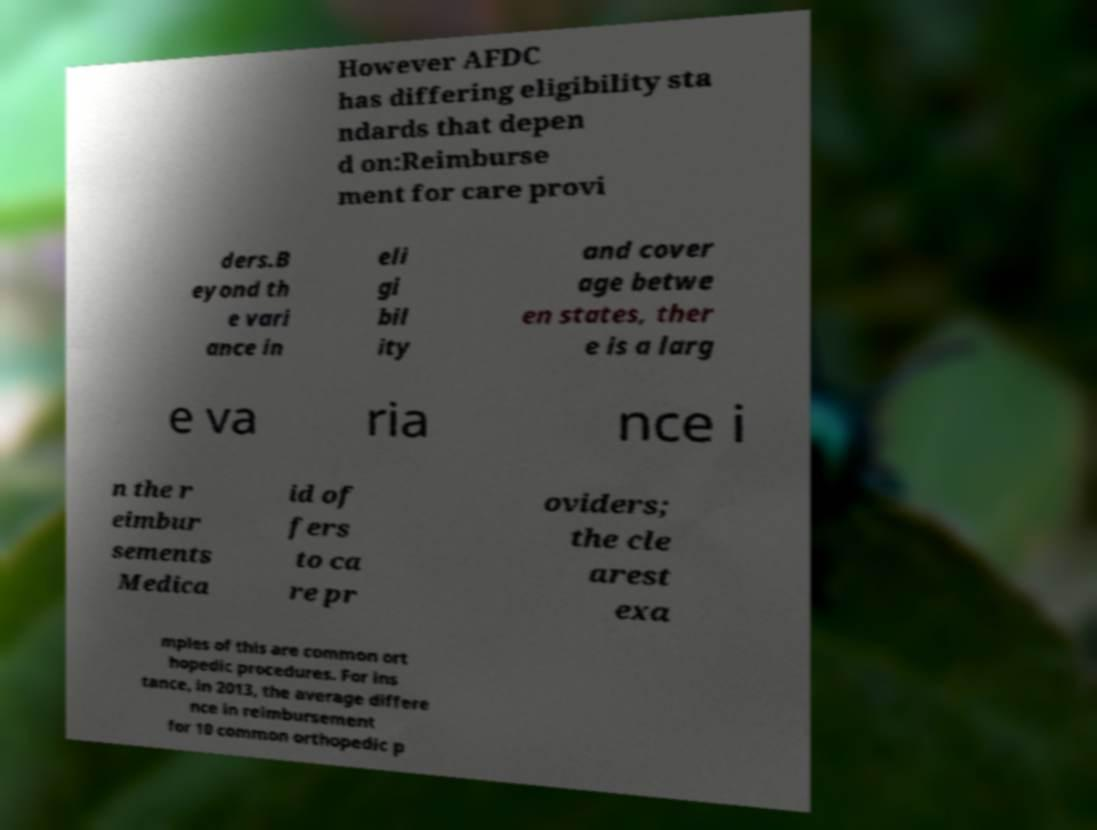Could you assist in decoding the text presented in this image and type it out clearly? However AFDC has differing eligibility sta ndards that depen d on:Reimburse ment for care provi ders.B eyond th e vari ance in eli gi bil ity and cover age betwe en states, ther e is a larg e va ria nce i n the r eimbur sements Medica id of fers to ca re pr oviders; the cle arest exa mples of this are common ort hopedic procedures. For ins tance, in 2013, the average differe nce in reimbursement for 10 common orthopedic p 